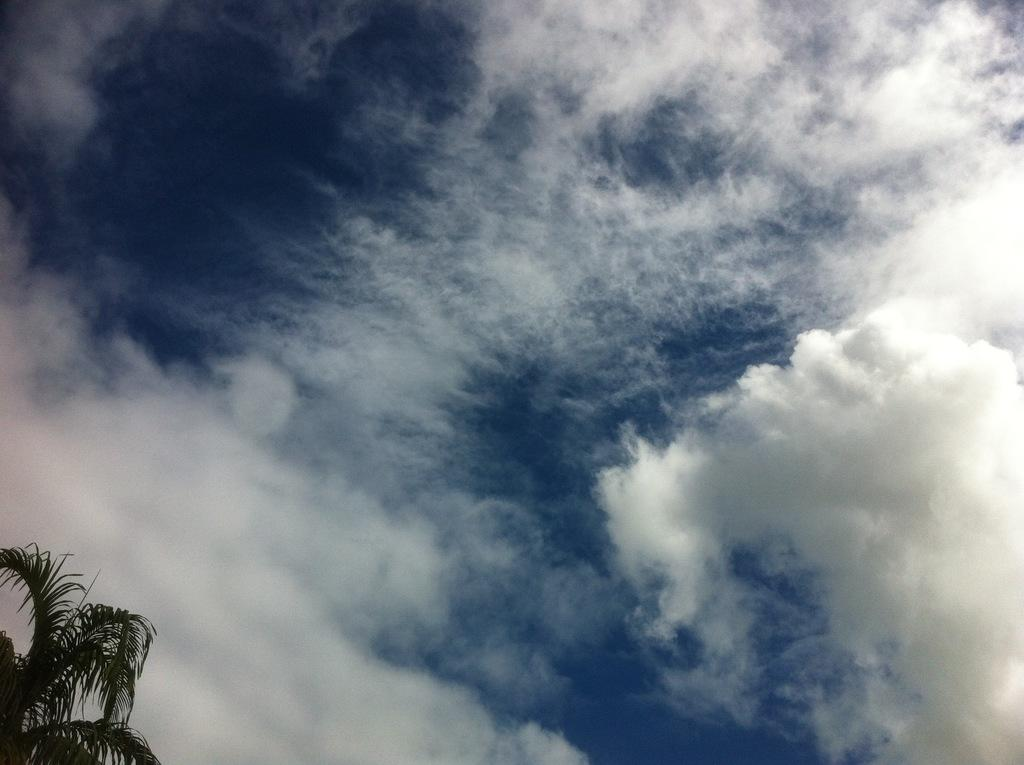What type of vegetation is present in the image? There is a tree in the image. What is the condition of the sky in the image? The sky is cloudy in the image. How many icicles are hanging from the tree in the image? There are no icicles present in the image, as it features a tree and a cloudy sky. 